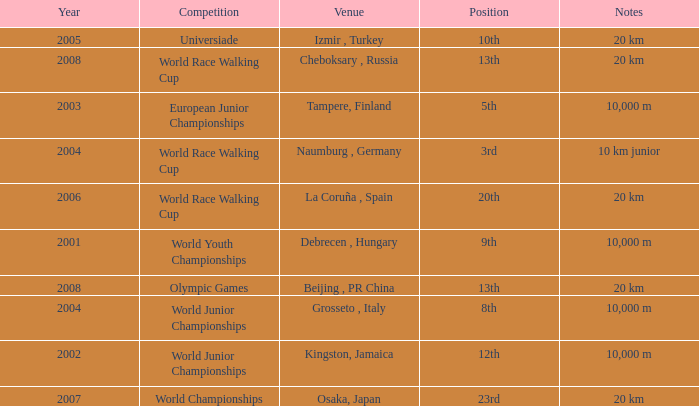What were the notes when his position was 10th? 20 km. 